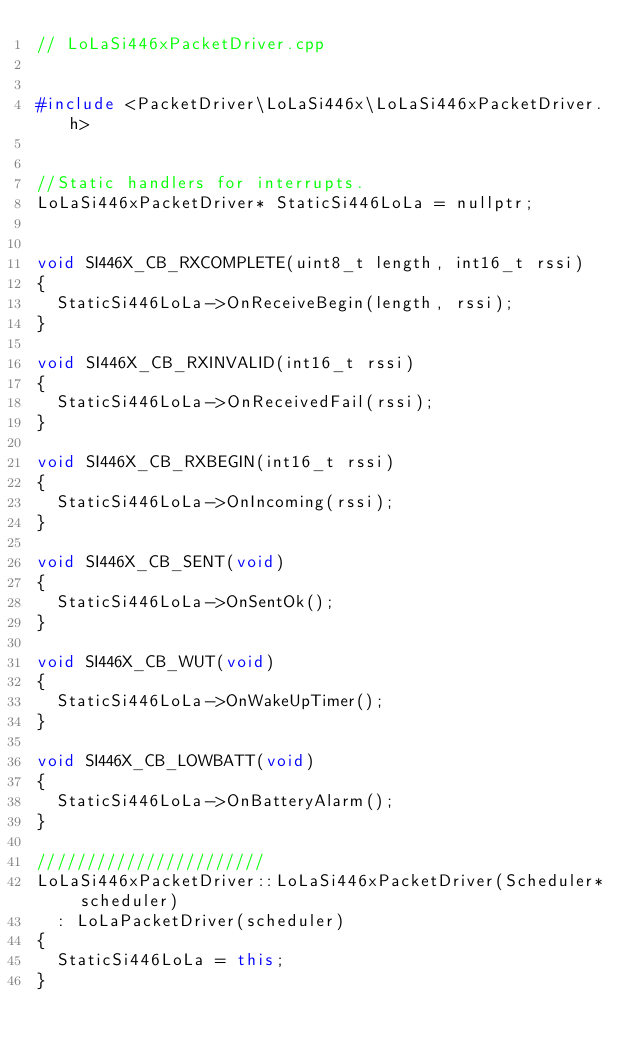Convert code to text. <code><loc_0><loc_0><loc_500><loc_500><_C++_>// LoLaSi446xPacketDriver.cpp


#include <PacketDriver\LoLaSi446x\LoLaSi446xPacketDriver.h>


//Static handlers for interrupts.
LoLaSi446xPacketDriver* StaticSi446LoLa = nullptr;


void SI446X_CB_RXCOMPLETE(uint8_t length, int16_t rssi)
{
	StaticSi446LoLa->OnReceiveBegin(length, rssi);
}

void SI446X_CB_RXINVALID(int16_t rssi)
{
	StaticSi446LoLa->OnReceivedFail(rssi);
}

void SI446X_CB_RXBEGIN(int16_t rssi)
{
	StaticSi446LoLa->OnIncoming(rssi);
}

void SI446X_CB_SENT(void)
{
	StaticSi446LoLa->OnSentOk();
}

void SI446X_CB_WUT(void)
{
	StaticSi446LoLa->OnWakeUpTimer();
}

void SI446X_CB_LOWBATT(void)
{
	StaticSi446LoLa->OnBatteryAlarm();
}

///////////////////////
LoLaSi446xPacketDriver::LoLaSi446xPacketDriver(Scheduler* scheduler)
	: LoLaPacketDriver(scheduler)
{
	StaticSi446LoLa = this;
}</code> 